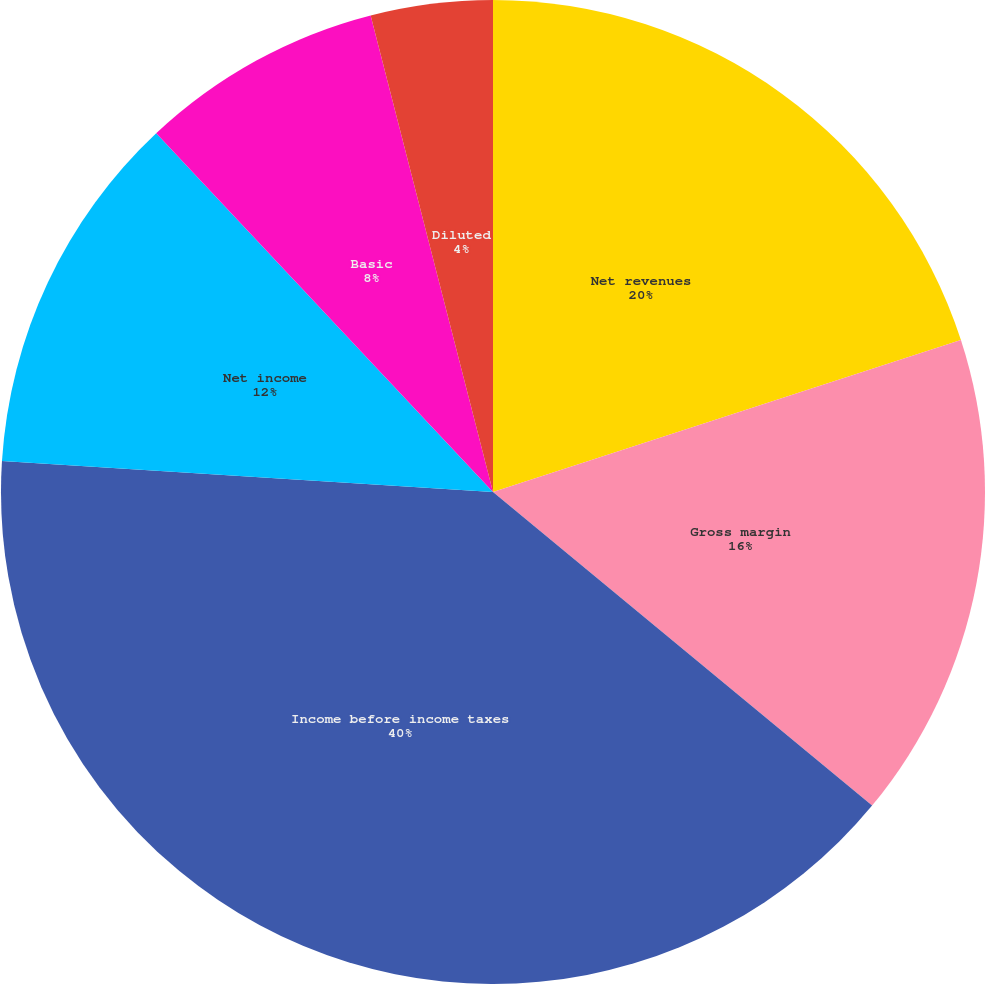Convert chart. <chart><loc_0><loc_0><loc_500><loc_500><pie_chart><fcel>Net revenues<fcel>Gross margin<fcel>Income before income taxes<fcel>Net income<fcel>Basic<fcel>Diluted<fcel>Cash dividends declared per<nl><fcel>20.0%<fcel>16.0%<fcel>40.0%<fcel>12.0%<fcel>8.0%<fcel>4.0%<fcel>0.0%<nl></chart> 